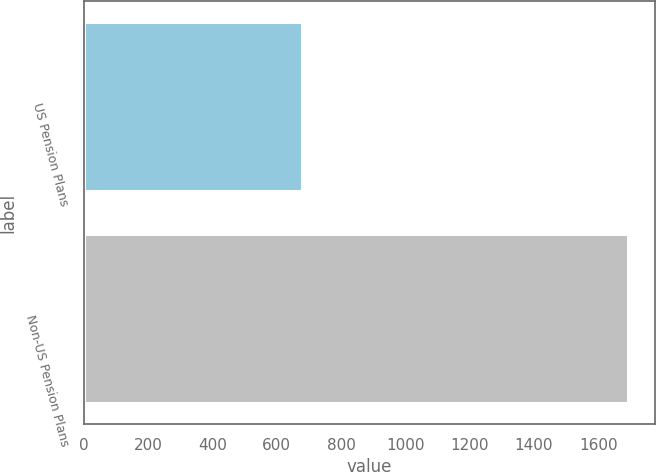Convert chart. <chart><loc_0><loc_0><loc_500><loc_500><bar_chart><fcel>US Pension Plans<fcel>Non-US Pension Plans<nl><fcel>678<fcel>1693<nl></chart> 